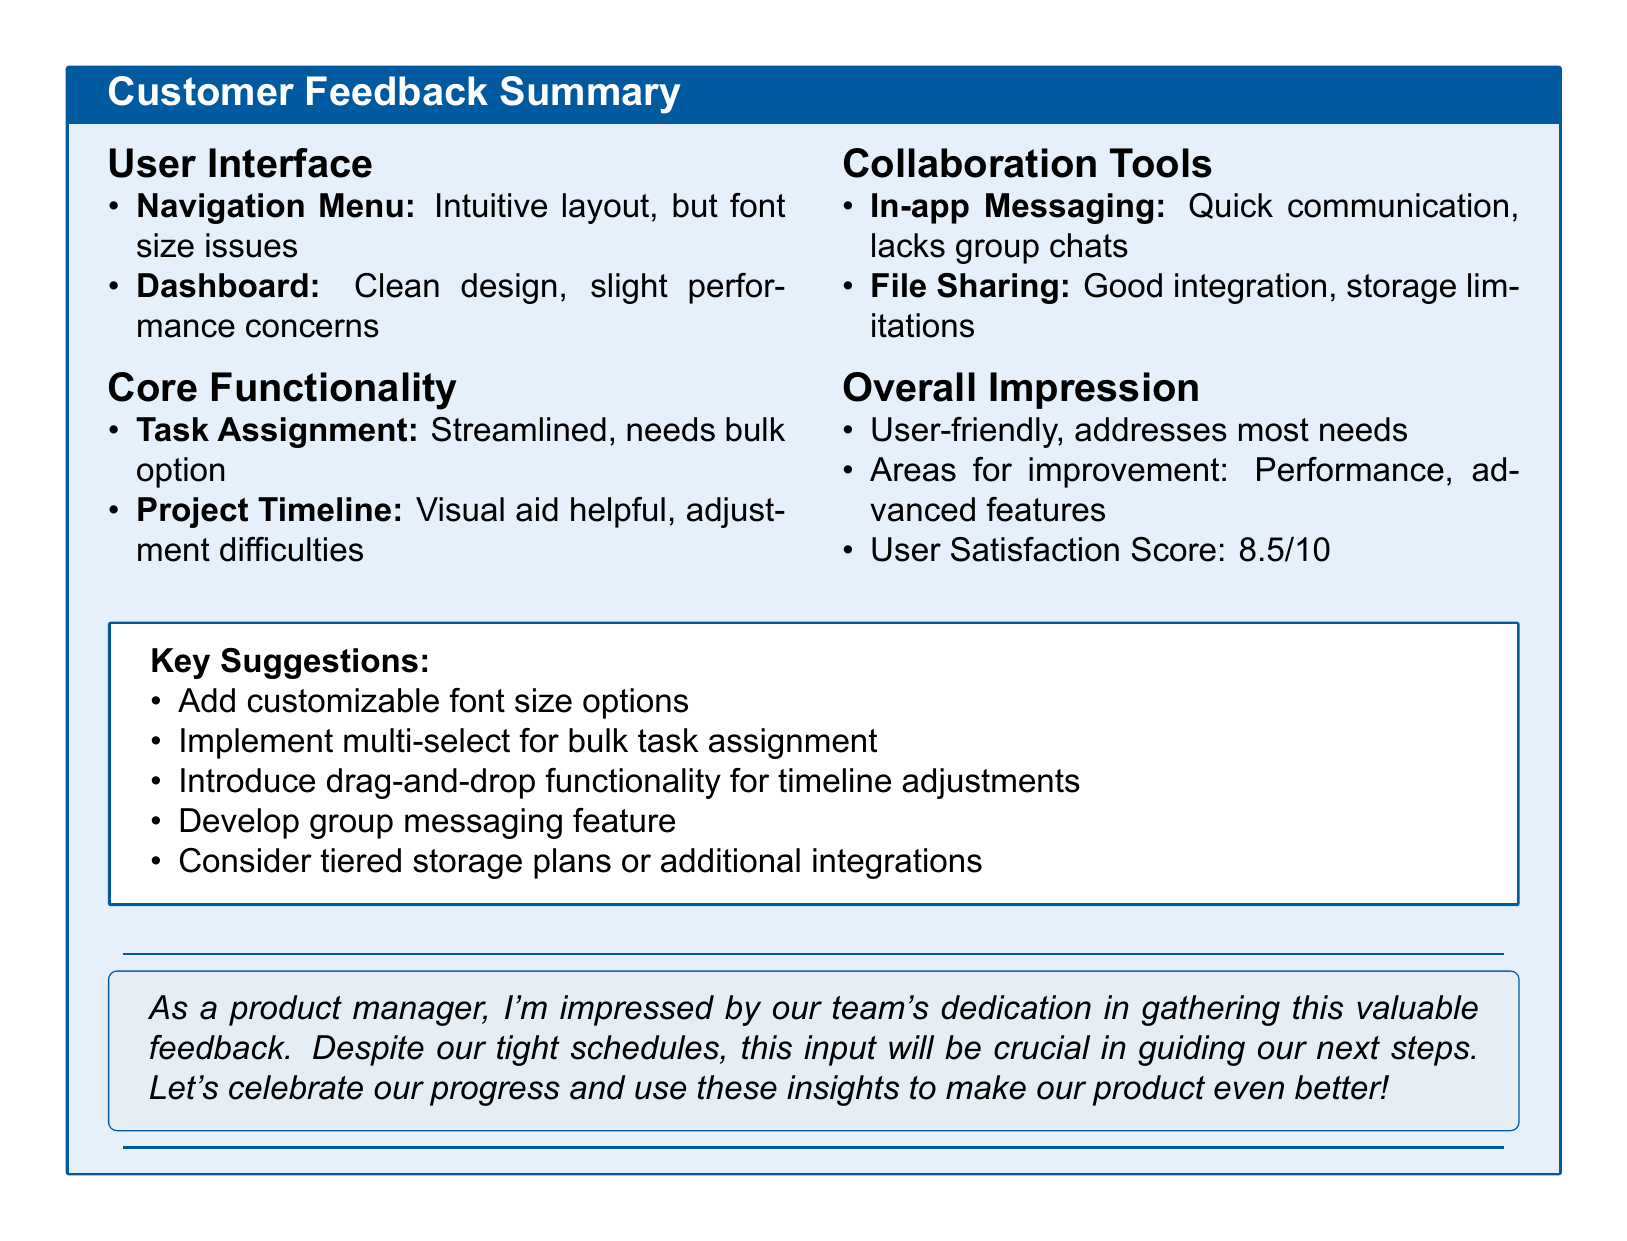What is the user satisfaction score? The user satisfaction score is presented under the overall impression section of the document.
Answer: 8.5 What is a positive aspect of the navigation menu? The positive aspect is mentioned as part of the user interface feedback.
Answer: Intuitive layout What feature is suggested for improving task assignment? This feature suggestion can be found under core functionality for task assignment.
Answer: Multi-select What is a notable negative about the dashboard? The negative feedback regarding the dashboard is discussed in the user interface section.
Answer: Loading time slightly slow on older devices What suggestion is given for file sharing? The suggestion for file sharing can be found in the collaboration tools section.
Answer: Consider tiered storage plans or integration with more services What overall impression is noted about the product? The overall impression is summarized towards the end of the document.
Answer: User-friendly, addresses most project management needs What is a concern mentioned about in-app messaging? The concern about in-app messaging is expressed under collaboration tools.
Answer: No option to create group chats Which feature needs a drag-and-drop functionality for adjustments? This need is highlighted under core functionality in relation to project timeline.
Answer: Project Timeline 